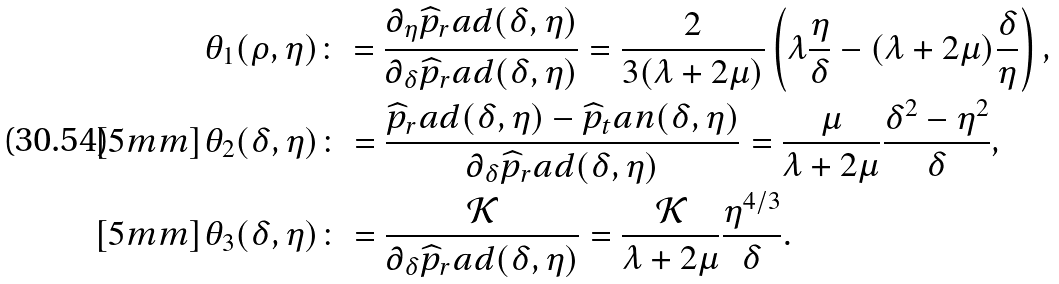Convert formula to latex. <formula><loc_0><loc_0><loc_500><loc_500>& \theta _ { 1 } ( \rho , \eta ) \colon = \frac { \partial _ { \eta } \widehat { p } _ { r } a d ( \delta , \eta ) } { \partial _ { \delta } \widehat { p } _ { r } a d ( \delta , \eta ) } = \frac { 2 } { 3 ( \lambda + 2 \mu ) } \left ( \lambda \frac { \eta } { \delta } - ( \lambda + 2 \mu ) \frac { \delta } { \eta } \right ) , \\ [ 5 m m ] & \theta _ { 2 } ( \delta , \eta ) \colon = \frac { \widehat { p } _ { r } a d ( \delta , \eta ) - \widehat { p } _ { t } a n ( \delta , \eta ) } { \partial _ { \delta } \widehat { p } _ { r } a d ( \delta , \eta ) } = \frac { \mu } { \lambda + 2 \mu } \frac { \delta ^ { 2 } - \eta ^ { 2 } } { \delta } , \\ [ 5 m m ] & \theta _ { 3 } ( \delta , \eta ) \colon = \frac { \mathcal { K } } { \partial _ { \delta } \widehat { p } _ { r } a d ( \delta , \eta ) } = \frac { \mathcal { K } } { \lambda + 2 \mu } \frac { \eta ^ { 4 / 3 } } { \delta } .</formula> 